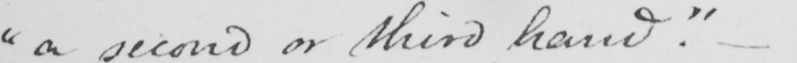What does this handwritten line say? " a second or third hand . "   _ 